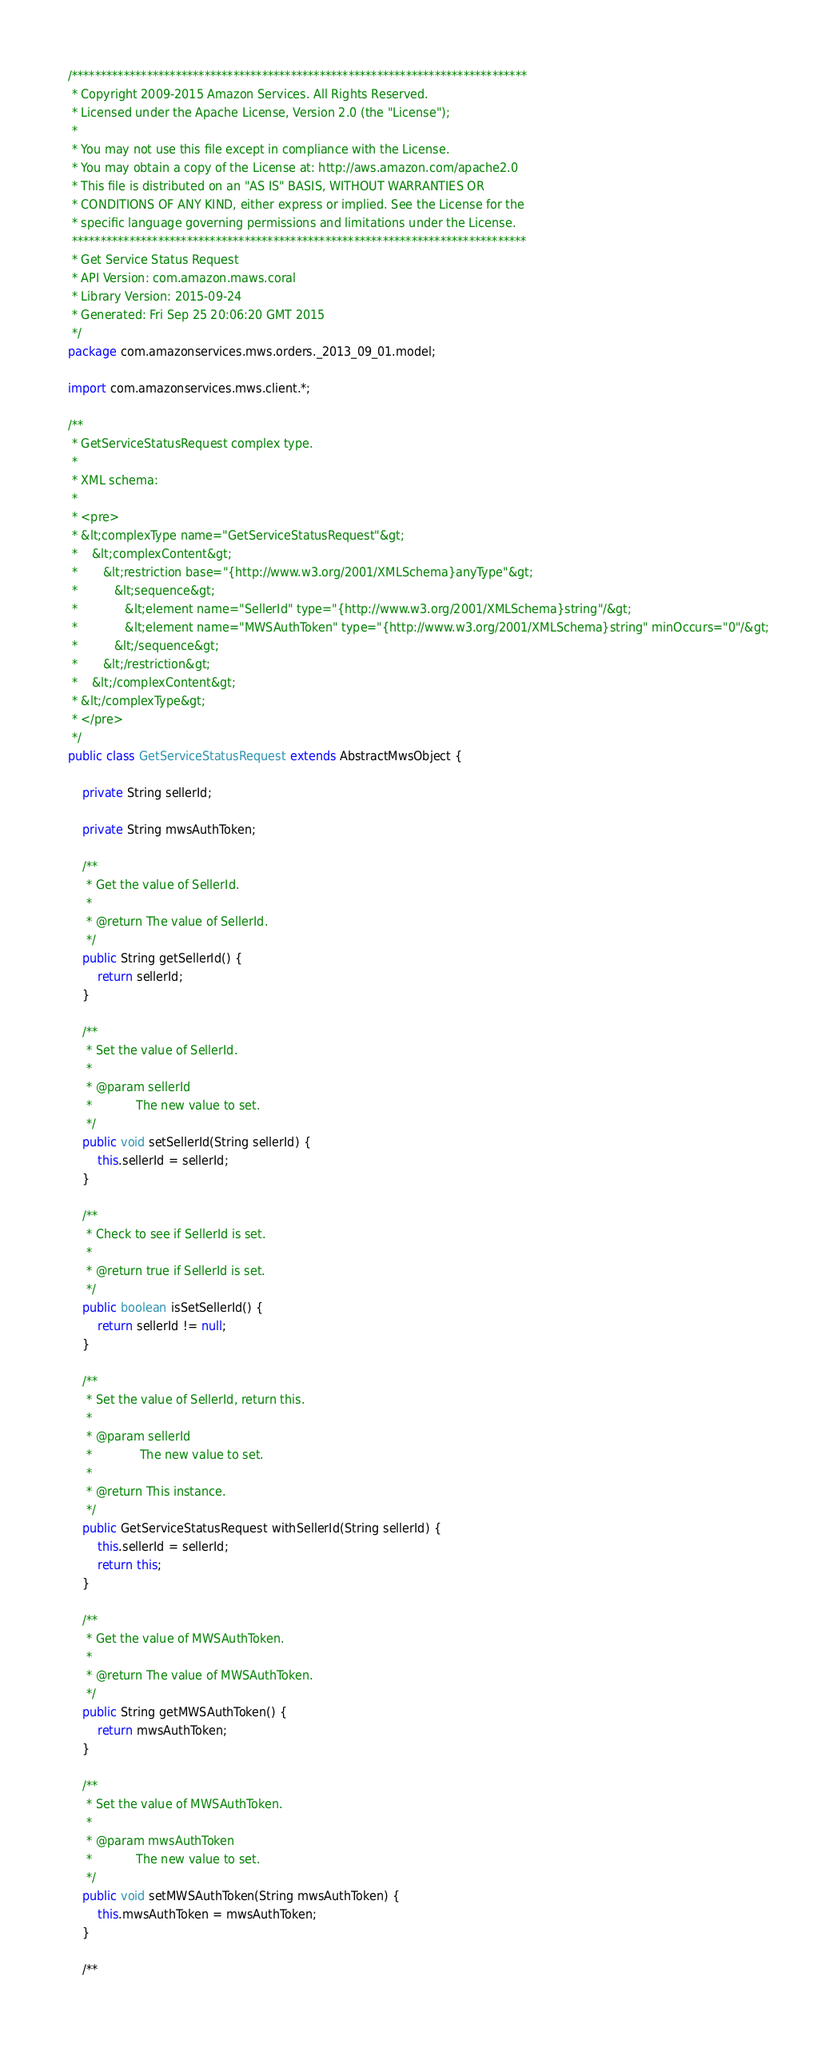<code> <loc_0><loc_0><loc_500><loc_500><_Java_>/*******************************************************************************
 * Copyright 2009-2015 Amazon Services. All Rights Reserved.
 * Licensed under the Apache License, Version 2.0 (the "License"); 
 *
 * You may not use this file except in compliance with the License. 
 * You may obtain a copy of the License at: http://aws.amazon.com/apache2.0
 * This file is distributed on an "AS IS" BASIS, WITHOUT WARRANTIES OR 
 * CONDITIONS OF ANY KIND, either express or implied. See the License for the 
 * specific language governing permissions and limitations under the License.
 *******************************************************************************
 * Get Service Status Request
 * API Version: com.amazon.maws.coral
 * Library Version: 2015-09-24
 * Generated: Fri Sep 25 20:06:20 GMT 2015
 */
package com.amazonservices.mws.orders._2013_09_01.model;

import com.amazonservices.mws.client.*;

/**
 * GetServiceStatusRequest complex type.
 *
 * XML schema:
 *
 * <pre>
 * &lt;complexType name="GetServiceStatusRequest"&gt;
 *    &lt;complexContent&gt;
 *       &lt;restriction base="{http://www.w3.org/2001/XMLSchema}anyType"&gt;
 *          &lt;sequence&gt;
 *             &lt;element name="SellerId" type="{http://www.w3.org/2001/XMLSchema}string"/&gt;
 *             &lt;element name="MWSAuthToken" type="{http://www.w3.org/2001/XMLSchema}string" minOccurs="0"/&gt;
 *          &lt;/sequence&gt;
 *       &lt;/restriction&gt;
 *    &lt;/complexContent&gt;
 * &lt;/complexType&gt;
 * </pre>
 */
public class GetServiceStatusRequest extends AbstractMwsObject {

    private String sellerId;

    private String mwsAuthToken;

    /**
     * Get the value of SellerId.
     *
     * @return The value of SellerId.
     */
    public String getSellerId() {
        return sellerId;
    }

    /**
     * Set the value of SellerId.
     *
     * @param sellerId
     *            The new value to set.
     */
    public void setSellerId(String sellerId) {
        this.sellerId = sellerId;
    }

    /**
     * Check to see if SellerId is set.
     *
     * @return true if SellerId is set.
     */
    public boolean isSetSellerId() {
        return sellerId != null;
    }

    /**
     * Set the value of SellerId, return this.
     *
     * @param sellerId
     *             The new value to set.
     *
     * @return This instance.
     */
    public GetServiceStatusRequest withSellerId(String sellerId) {
        this.sellerId = sellerId;
        return this;
    }

    /**
     * Get the value of MWSAuthToken.
     *
     * @return The value of MWSAuthToken.
     */
    public String getMWSAuthToken() {
        return mwsAuthToken;
    }

    /**
     * Set the value of MWSAuthToken.
     *
     * @param mwsAuthToken
     *            The new value to set.
     */
    public void setMWSAuthToken(String mwsAuthToken) {
        this.mwsAuthToken = mwsAuthToken;
    }

    /**</code> 